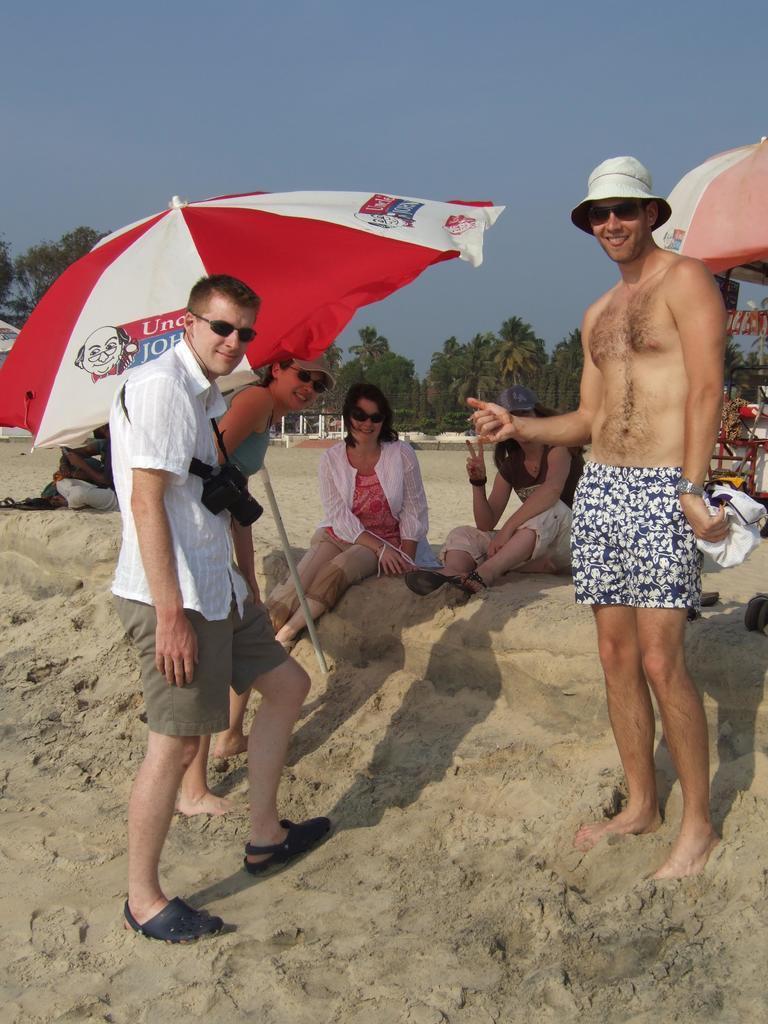Please provide a concise description of this image. There are two men and a woman standing and smiling. These look like the beach umbrellas. I can see two women sitting on the sand. In the background, I can see the trees. 